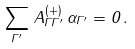Convert formula to latex. <formula><loc_0><loc_0><loc_500><loc_500>\sum _ { \Gamma ^ { \prime } } \, A ^ { ( + ) } _ { \Gamma \Gamma ^ { \prime } } \, \alpha _ { \Gamma ^ { \prime } } = 0 \, .</formula> 